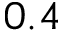Convert formula to latex. <formula><loc_0><loc_0><loc_500><loc_500>0 . 4</formula> 